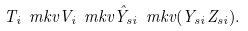Convert formula to latex. <formula><loc_0><loc_0><loc_500><loc_500>T _ { i } \ m k v V _ { i } \ m k v \hat { Y } _ { s i } \ m k v ( Y _ { s i } Z _ { s i } ) .</formula> 